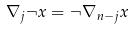<formula> <loc_0><loc_0><loc_500><loc_500>\nabla _ { j } \neg x = \neg \nabla _ { n - j } x</formula> 